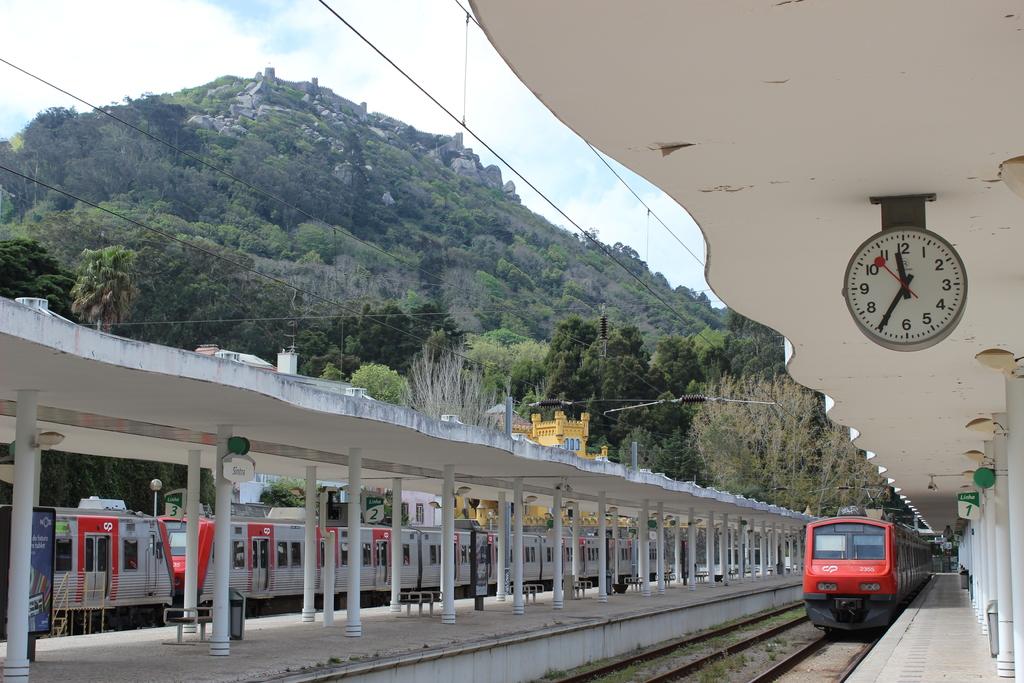What time is it?
Your answer should be very brief. 11:35. 